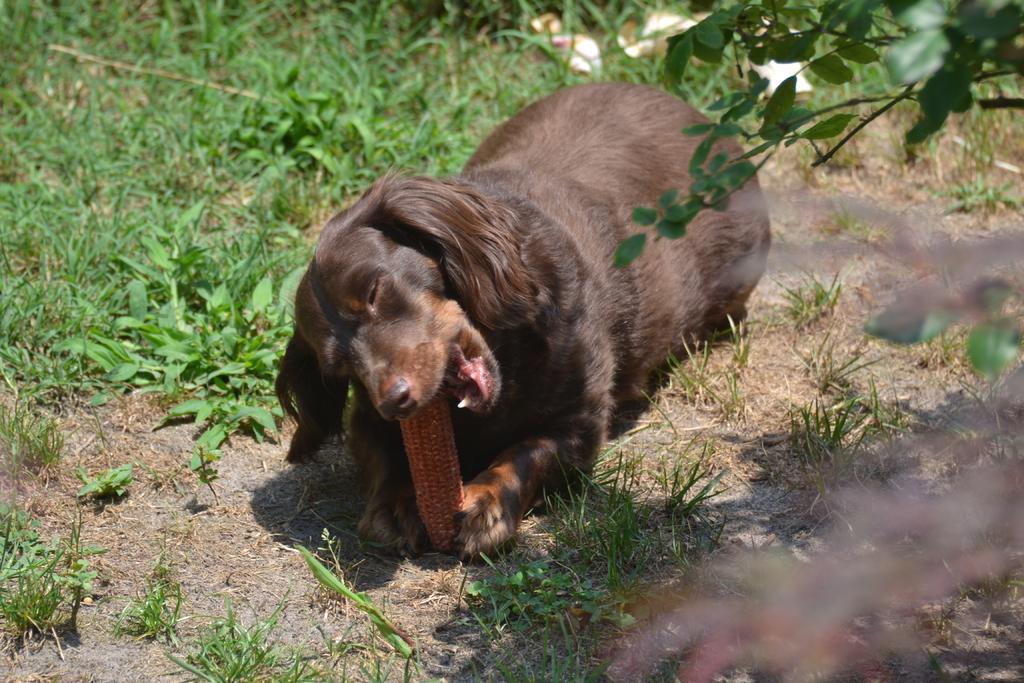Can you describe this image briefly? In this image we can see a dog biting a stick. We can also see some grass and the plants. 